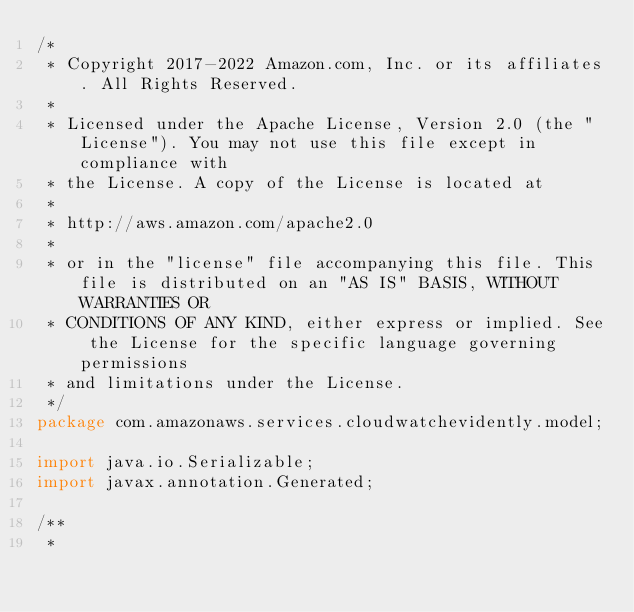Convert code to text. <code><loc_0><loc_0><loc_500><loc_500><_Java_>/*
 * Copyright 2017-2022 Amazon.com, Inc. or its affiliates. All Rights Reserved.
 * 
 * Licensed under the Apache License, Version 2.0 (the "License"). You may not use this file except in compliance with
 * the License. A copy of the License is located at
 * 
 * http://aws.amazon.com/apache2.0
 * 
 * or in the "license" file accompanying this file. This file is distributed on an "AS IS" BASIS, WITHOUT WARRANTIES OR
 * CONDITIONS OF ANY KIND, either express or implied. See the License for the specific language governing permissions
 * and limitations under the License.
 */
package com.amazonaws.services.cloudwatchevidently.model;

import java.io.Serializable;
import javax.annotation.Generated;

/**
 * </code> 